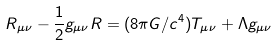Convert formula to latex. <formula><loc_0><loc_0><loc_500><loc_500>R _ { \mu \nu } - \frac { 1 } { 2 } g _ { \mu \nu } R = ( 8 \pi G / c ^ { 4 } ) T _ { \mu \nu } + \Lambda g _ { \mu \nu }</formula> 